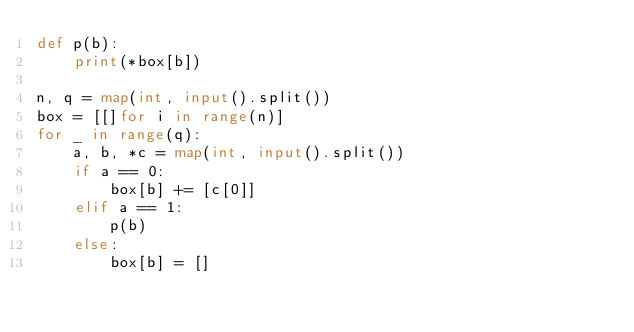Convert code to text. <code><loc_0><loc_0><loc_500><loc_500><_Python_>def p(b):
    print(*box[b])

n, q = map(int, input().split())
box = [[]for i in range(n)]
for _ in range(q):
    a, b, *c = map(int, input().split())
    if a == 0:
        box[b] += [c[0]]
    elif a == 1:
        p(b)
    else:
        box[b] = []

</code> 